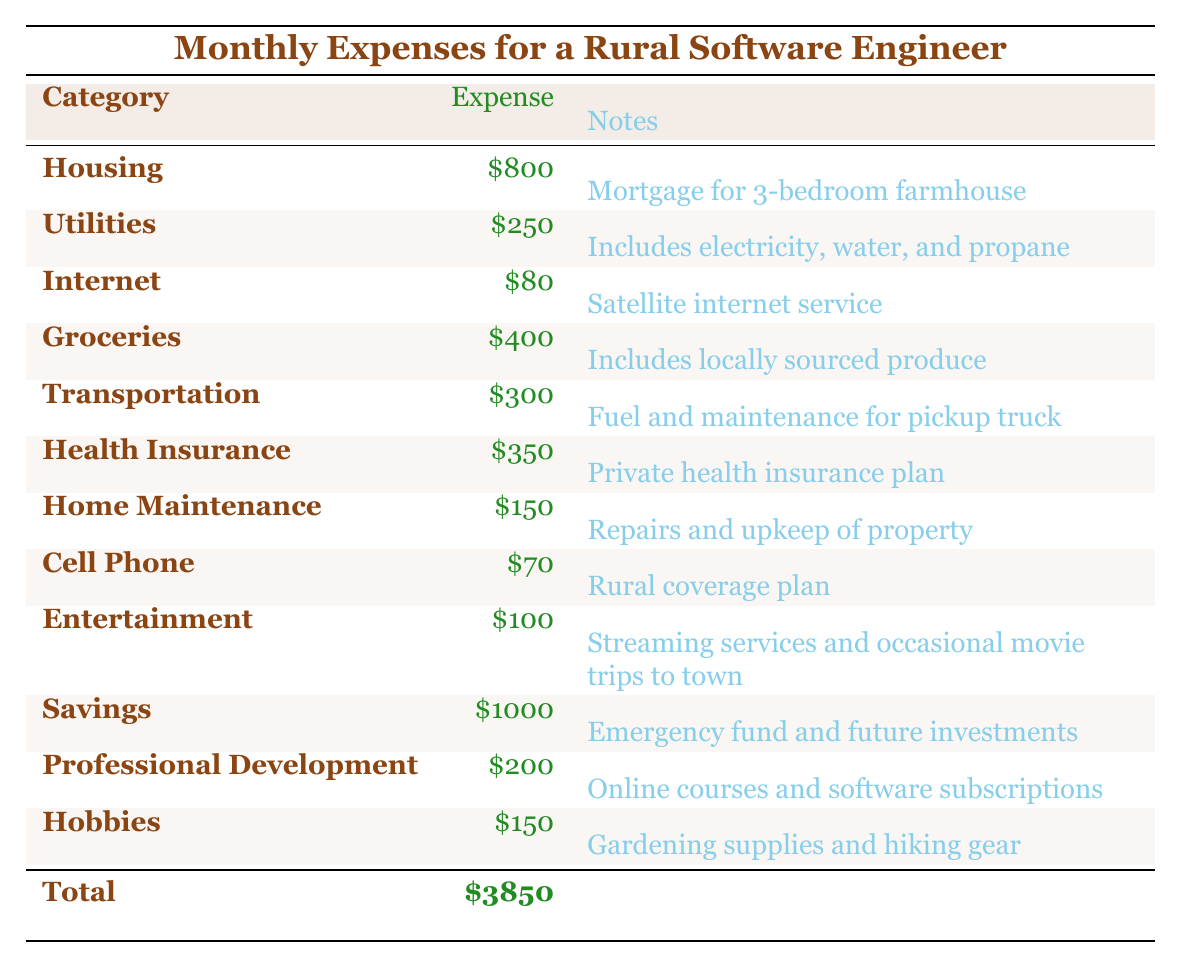What is the total monthly expense of the software engineer? The total monthly expense is clearly listed at the bottom of the table, summing all the individual expenses from each category. The total amount is \$3850.
Answer: \$3850 How much does the software engineer spend on groceries? The table states under the "Groceries" category that the expense is \$400.
Answer: \$400 Is the expense for internet higher than for cell phone? The expense for internet is \$80 and for cell phone is \$70. Comparing these values shows that internet expense is higher.
Answer: Yes What is the difference between the highest and lowest expense categories? The highest expense is for "Savings" at \$1000 and the lowest is for "Internet" at \$80. The difference can be calculated as \$1000 - \$80 = \$920.
Answer: \$920 If the software engineer saves \$1000 a month, how much does he spend in total on necessities (excluding savings)? The total expense excluding savings is calculated by summing the other expense categories, resulting in \$3850 - \$1000 = \$2850.
Answer: \$2850 What fraction of the total monthly expenses is allocated for health insurance? The health insurance expense is \$350. To find the fraction, we divide it by the total expenses: \$350 / \$3850 = 0.0909, which is approximately 9.09%.
Answer: 9.09% How much does the software engineer spend on entertainment compared to transportation? The expense for entertainment is \$100 and for transportation is \$300. The comparison shows transportation is three times higher than entertainment.
Answer: Transportation is three times higher What is the average expense for utilities, health insurance, and transportation? The individual expenses are \$250, \$350, and \$300 respectively. Summing these gives \$250 + \$350 + \$300 = \$900. To find the average, we divide by 3: \$900 / 3 = \$300.
Answer: \$300 Are the combined expenses for hobbies and home maintenance greater than the expense for groceries? The expenses for hobbies and home maintenance are \$150 and \$150 respectively, combining to \$150 + \$150 = \$300. Groceries are \$400, so \$300 is less than \$400.
Answer: No If the software engineer cuts his entertainment expenses by half, what would the new total monthly expenses be? Cutting entertainment by half means reducing \$100 to \$50. The new total would be \$3850 - \$100 + \$50 = \$3800.
Answer: \$3800 